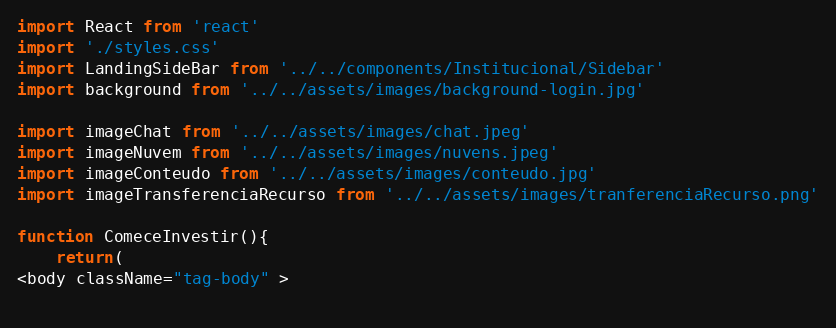Convert code to text. <code><loc_0><loc_0><loc_500><loc_500><_TypeScript_>import React from 'react'
import './styles.css'
import LandingSideBar from '../../components/Institucional/Sidebar'
import background from '../../assets/images/background-login.jpg'

import imageChat from '../../assets/images/chat.jpeg'
import imageNuvem from '../../assets/images/nuvens.jpeg'
import imageConteudo from '../../assets/images/conteudo.jpg'
import imageTransferenciaRecurso from '../../assets/images/tranferenciaRecurso.png'

function ComeceInvestir(){
    return(
<body className="tag-body" >
       </code> 